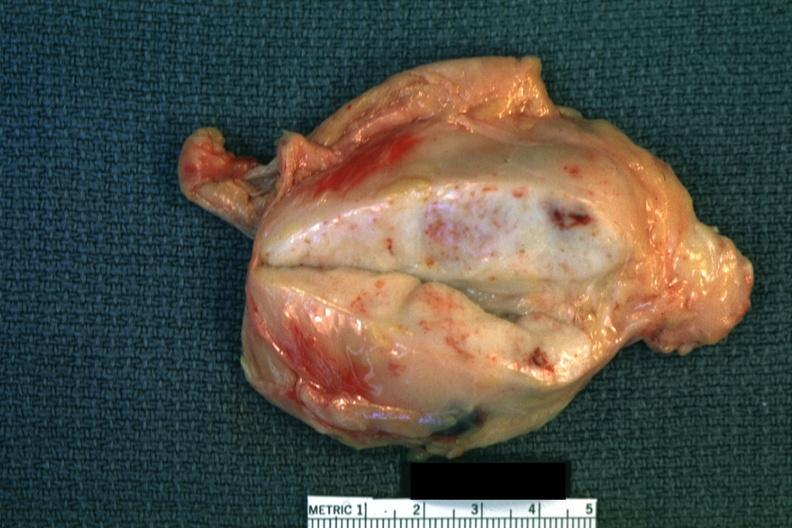what does close-up enlarge?
Answer the question using a single word or phrase. Up enlarge white node with focal necrosis quite good 